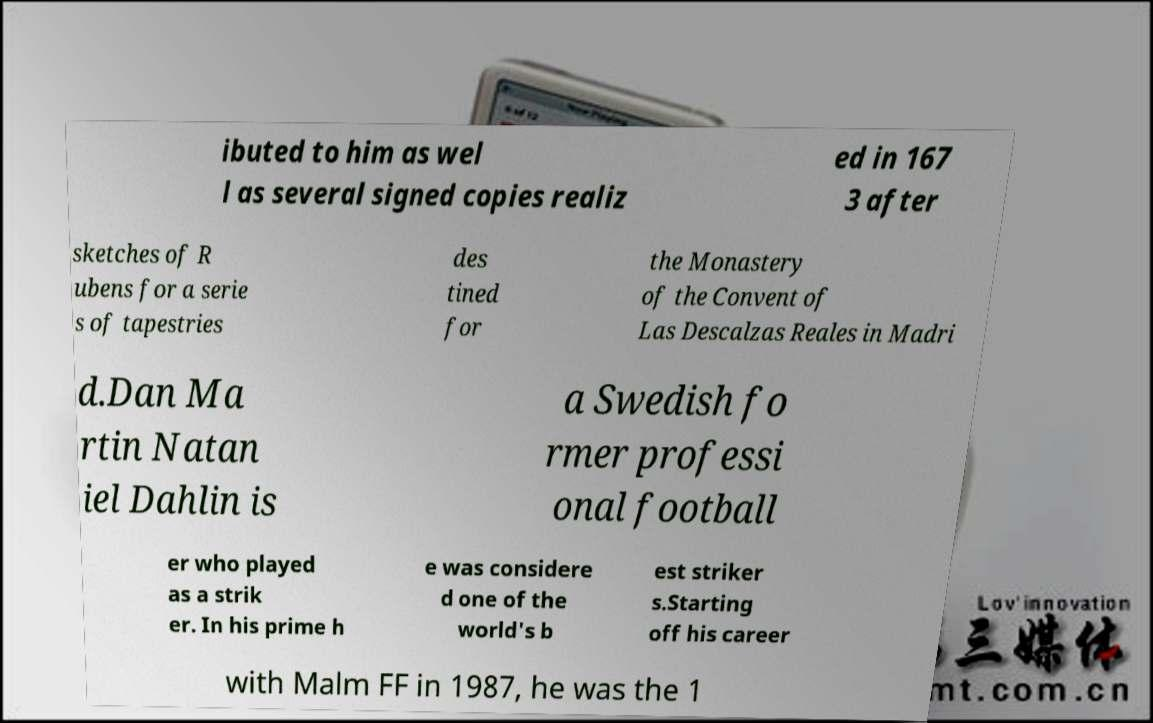Can you read and provide the text displayed in the image?This photo seems to have some interesting text. Can you extract and type it out for me? ibuted to him as wel l as several signed copies realiz ed in 167 3 after sketches of R ubens for a serie s of tapestries des tined for the Monastery of the Convent of Las Descalzas Reales in Madri d.Dan Ma rtin Natan iel Dahlin is a Swedish fo rmer professi onal football er who played as a strik er. In his prime h e was considere d one of the world's b est striker s.Starting off his career with Malm FF in 1987, he was the 1 